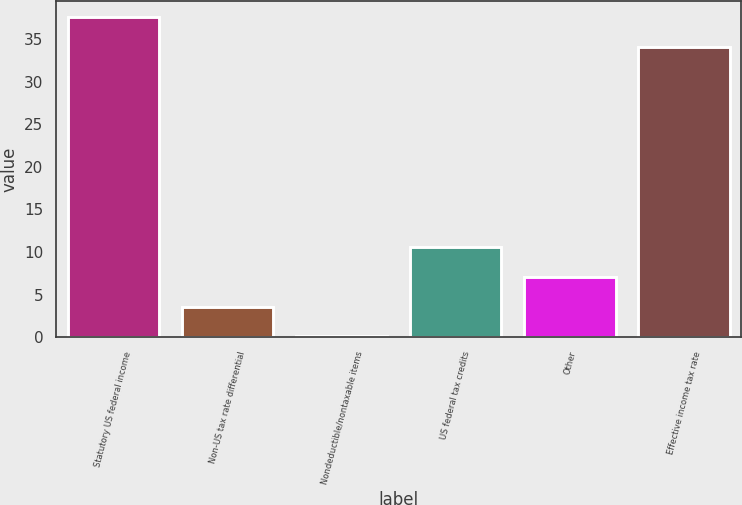<chart> <loc_0><loc_0><loc_500><loc_500><bar_chart><fcel>Statutory US federal income<fcel>Non-US tax rate differential<fcel>Nondeductible/nontaxable items<fcel>US federal tax credits<fcel>Other<fcel>Effective income tax rate<nl><fcel>37.59<fcel>3.59<fcel>0.1<fcel>10.57<fcel>7.08<fcel>34.1<nl></chart> 